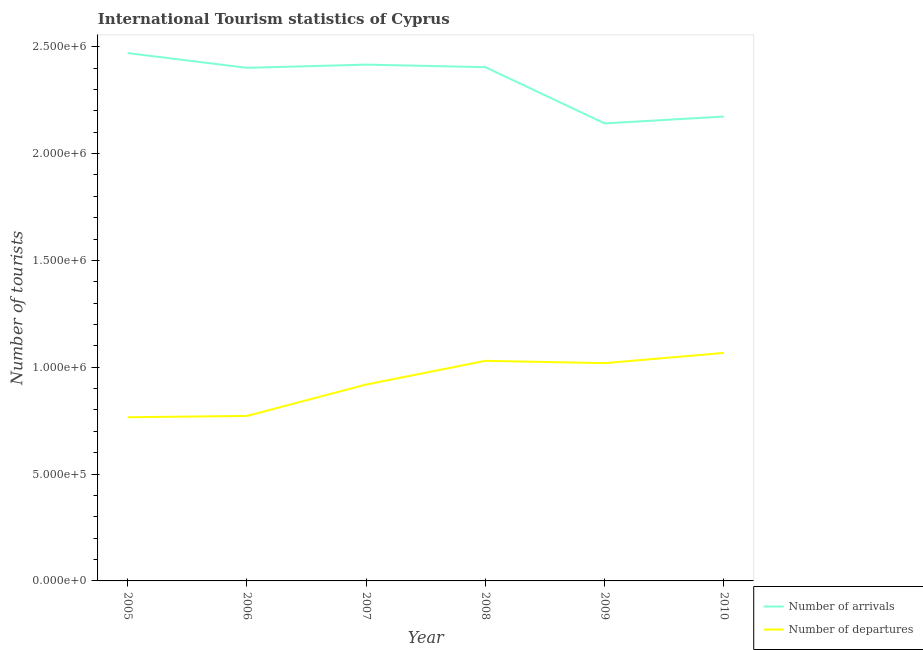Does the line corresponding to number of tourist arrivals intersect with the line corresponding to number of tourist departures?
Ensure brevity in your answer.  No. Is the number of lines equal to the number of legend labels?
Your answer should be very brief. Yes. What is the number of tourist arrivals in 2007?
Your response must be concise. 2.42e+06. Across all years, what is the maximum number of tourist departures?
Offer a very short reply. 1.07e+06. Across all years, what is the minimum number of tourist departures?
Provide a short and direct response. 7.66e+05. In which year was the number of tourist arrivals maximum?
Offer a very short reply. 2005. In which year was the number of tourist arrivals minimum?
Offer a terse response. 2009. What is the total number of tourist arrivals in the graph?
Make the answer very short. 1.40e+07. What is the difference between the number of tourist arrivals in 2009 and that in 2010?
Provide a succinct answer. -3.20e+04. What is the difference between the number of tourist arrivals in 2006 and the number of tourist departures in 2008?
Your response must be concise. 1.37e+06. What is the average number of tourist arrivals per year?
Give a very brief answer. 2.33e+06. In the year 2008, what is the difference between the number of tourist departures and number of tourist arrivals?
Ensure brevity in your answer.  -1.37e+06. What is the ratio of the number of tourist departures in 2007 to that in 2010?
Offer a terse response. 0.86. Is the number of tourist arrivals in 2006 less than that in 2008?
Your answer should be compact. Yes. Is the difference between the number of tourist departures in 2005 and 2007 greater than the difference between the number of tourist arrivals in 2005 and 2007?
Give a very brief answer. No. What is the difference between the highest and the second highest number of tourist departures?
Offer a very short reply. 3.70e+04. What is the difference between the highest and the lowest number of tourist arrivals?
Provide a succinct answer. 3.29e+05. In how many years, is the number of tourist arrivals greater than the average number of tourist arrivals taken over all years?
Your answer should be very brief. 4. Is the number of tourist departures strictly less than the number of tourist arrivals over the years?
Your response must be concise. Yes. How many lines are there?
Make the answer very short. 2. How many years are there in the graph?
Offer a terse response. 6. What is the difference between two consecutive major ticks on the Y-axis?
Offer a terse response. 5.00e+05. Are the values on the major ticks of Y-axis written in scientific E-notation?
Keep it short and to the point. Yes. Where does the legend appear in the graph?
Your response must be concise. Bottom right. What is the title of the graph?
Offer a very short reply. International Tourism statistics of Cyprus. Does "Export" appear as one of the legend labels in the graph?
Offer a terse response. No. What is the label or title of the X-axis?
Offer a terse response. Year. What is the label or title of the Y-axis?
Your answer should be compact. Number of tourists. What is the Number of tourists in Number of arrivals in 2005?
Ensure brevity in your answer.  2.47e+06. What is the Number of tourists in Number of departures in 2005?
Give a very brief answer. 7.66e+05. What is the Number of tourists in Number of arrivals in 2006?
Offer a terse response. 2.40e+06. What is the Number of tourists in Number of departures in 2006?
Your response must be concise. 7.72e+05. What is the Number of tourists in Number of arrivals in 2007?
Give a very brief answer. 2.42e+06. What is the Number of tourists in Number of departures in 2007?
Give a very brief answer. 9.19e+05. What is the Number of tourists in Number of arrivals in 2008?
Provide a short and direct response. 2.40e+06. What is the Number of tourists in Number of departures in 2008?
Make the answer very short. 1.03e+06. What is the Number of tourists in Number of arrivals in 2009?
Offer a terse response. 2.14e+06. What is the Number of tourists of Number of departures in 2009?
Make the answer very short. 1.02e+06. What is the Number of tourists of Number of arrivals in 2010?
Provide a short and direct response. 2.17e+06. What is the Number of tourists in Number of departures in 2010?
Ensure brevity in your answer.  1.07e+06. Across all years, what is the maximum Number of tourists in Number of arrivals?
Your answer should be compact. 2.47e+06. Across all years, what is the maximum Number of tourists of Number of departures?
Your response must be concise. 1.07e+06. Across all years, what is the minimum Number of tourists in Number of arrivals?
Provide a succinct answer. 2.14e+06. Across all years, what is the minimum Number of tourists in Number of departures?
Your answer should be compact. 7.66e+05. What is the total Number of tourists of Number of arrivals in the graph?
Your answer should be compact. 1.40e+07. What is the total Number of tourists of Number of departures in the graph?
Make the answer very short. 5.57e+06. What is the difference between the Number of tourists in Number of arrivals in 2005 and that in 2006?
Your response must be concise. 6.90e+04. What is the difference between the Number of tourists of Number of departures in 2005 and that in 2006?
Make the answer very short. -6000. What is the difference between the Number of tourists in Number of arrivals in 2005 and that in 2007?
Your answer should be compact. 5.40e+04. What is the difference between the Number of tourists of Number of departures in 2005 and that in 2007?
Your answer should be very brief. -1.53e+05. What is the difference between the Number of tourists of Number of arrivals in 2005 and that in 2008?
Your response must be concise. 6.60e+04. What is the difference between the Number of tourists in Number of departures in 2005 and that in 2008?
Offer a very short reply. -2.64e+05. What is the difference between the Number of tourists in Number of arrivals in 2005 and that in 2009?
Provide a short and direct response. 3.29e+05. What is the difference between the Number of tourists in Number of departures in 2005 and that in 2009?
Offer a terse response. -2.53e+05. What is the difference between the Number of tourists of Number of arrivals in 2005 and that in 2010?
Your answer should be very brief. 2.97e+05. What is the difference between the Number of tourists of Number of departures in 2005 and that in 2010?
Offer a terse response. -3.01e+05. What is the difference between the Number of tourists of Number of arrivals in 2006 and that in 2007?
Your response must be concise. -1.50e+04. What is the difference between the Number of tourists in Number of departures in 2006 and that in 2007?
Offer a terse response. -1.47e+05. What is the difference between the Number of tourists in Number of arrivals in 2006 and that in 2008?
Offer a very short reply. -3000. What is the difference between the Number of tourists in Number of departures in 2006 and that in 2008?
Provide a short and direct response. -2.58e+05. What is the difference between the Number of tourists of Number of arrivals in 2006 and that in 2009?
Ensure brevity in your answer.  2.60e+05. What is the difference between the Number of tourists of Number of departures in 2006 and that in 2009?
Your response must be concise. -2.47e+05. What is the difference between the Number of tourists of Number of arrivals in 2006 and that in 2010?
Offer a very short reply. 2.28e+05. What is the difference between the Number of tourists in Number of departures in 2006 and that in 2010?
Give a very brief answer. -2.95e+05. What is the difference between the Number of tourists of Number of arrivals in 2007 and that in 2008?
Give a very brief answer. 1.20e+04. What is the difference between the Number of tourists in Number of departures in 2007 and that in 2008?
Make the answer very short. -1.11e+05. What is the difference between the Number of tourists of Number of arrivals in 2007 and that in 2009?
Give a very brief answer. 2.75e+05. What is the difference between the Number of tourists in Number of arrivals in 2007 and that in 2010?
Provide a succinct answer. 2.43e+05. What is the difference between the Number of tourists of Number of departures in 2007 and that in 2010?
Provide a short and direct response. -1.48e+05. What is the difference between the Number of tourists of Number of arrivals in 2008 and that in 2009?
Your answer should be very brief. 2.63e+05. What is the difference between the Number of tourists of Number of departures in 2008 and that in 2009?
Your response must be concise. 1.10e+04. What is the difference between the Number of tourists of Number of arrivals in 2008 and that in 2010?
Ensure brevity in your answer.  2.31e+05. What is the difference between the Number of tourists of Number of departures in 2008 and that in 2010?
Make the answer very short. -3.70e+04. What is the difference between the Number of tourists of Number of arrivals in 2009 and that in 2010?
Offer a very short reply. -3.20e+04. What is the difference between the Number of tourists in Number of departures in 2009 and that in 2010?
Make the answer very short. -4.80e+04. What is the difference between the Number of tourists of Number of arrivals in 2005 and the Number of tourists of Number of departures in 2006?
Make the answer very short. 1.70e+06. What is the difference between the Number of tourists of Number of arrivals in 2005 and the Number of tourists of Number of departures in 2007?
Keep it short and to the point. 1.55e+06. What is the difference between the Number of tourists in Number of arrivals in 2005 and the Number of tourists in Number of departures in 2008?
Your response must be concise. 1.44e+06. What is the difference between the Number of tourists in Number of arrivals in 2005 and the Number of tourists in Number of departures in 2009?
Offer a very short reply. 1.45e+06. What is the difference between the Number of tourists in Number of arrivals in 2005 and the Number of tourists in Number of departures in 2010?
Provide a succinct answer. 1.40e+06. What is the difference between the Number of tourists in Number of arrivals in 2006 and the Number of tourists in Number of departures in 2007?
Offer a very short reply. 1.48e+06. What is the difference between the Number of tourists in Number of arrivals in 2006 and the Number of tourists in Number of departures in 2008?
Offer a terse response. 1.37e+06. What is the difference between the Number of tourists in Number of arrivals in 2006 and the Number of tourists in Number of departures in 2009?
Your answer should be very brief. 1.38e+06. What is the difference between the Number of tourists of Number of arrivals in 2006 and the Number of tourists of Number of departures in 2010?
Your answer should be very brief. 1.33e+06. What is the difference between the Number of tourists in Number of arrivals in 2007 and the Number of tourists in Number of departures in 2008?
Offer a terse response. 1.39e+06. What is the difference between the Number of tourists of Number of arrivals in 2007 and the Number of tourists of Number of departures in 2009?
Keep it short and to the point. 1.40e+06. What is the difference between the Number of tourists of Number of arrivals in 2007 and the Number of tourists of Number of departures in 2010?
Give a very brief answer. 1.35e+06. What is the difference between the Number of tourists in Number of arrivals in 2008 and the Number of tourists in Number of departures in 2009?
Offer a terse response. 1.38e+06. What is the difference between the Number of tourists of Number of arrivals in 2008 and the Number of tourists of Number of departures in 2010?
Keep it short and to the point. 1.34e+06. What is the difference between the Number of tourists in Number of arrivals in 2009 and the Number of tourists in Number of departures in 2010?
Your answer should be very brief. 1.07e+06. What is the average Number of tourists in Number of arrivals per year?
Keep it short and to the point. 2.33e+06. What is the average Number of tourists of Number of departures per year?
Provide a short and direct response. 9.29e+05. In the year 2005, what is the difference between the Number of tourists in Number of arrivals and Number of tourists in Number of departures?
Offer a terse response. 1.70e+06. In the year 2006, what is the difference between the Number of tourists in Number of arrivals and Number of tourists in Number of departures?
Provide a short and direct response. 1.63e+06. In the year 2007, what is the difference between the Number of tourists in Number of arrivals and Number of tourists in Number of departures?
Provide a short and direct response. 1.50e+06. In the year 2008, what is the difference between the Number of tourists in Number of arrivals and Number of tourists in Number of departures?
Your answer should be compact. 1.37e+06. In the year 2009, what is the difference between the Number of tourists in Number of arrivals and Number of tourists in Number of departures?
Offer a very short reply. 1.12e+06. In the year 2010, what is the difference between the Number of tourists of Number of arrivals and Number of tourists of Number of departures?
Give a very brief answer. 1.11e+06. What is the ratio of the Number of tourists of Number of arrivals in 2005 to that in 2006?
Offer a terse response. 1.03. What is the ratio of the Number of tourists in Number of departures in 2005 to that in 2006?
Your response must be concise. 0.99. What is the ratio of the Number of tourists of Number of arrivals in 2005 to that in 2007?
Offer a terse response. 1.02. What is the ratio of the Number of tourists in Number of departures in 2005 to that in 2007?
Ensure brevity in your answer.  0.83. What is the ratio of the Number of tourists of Number of arrivals in 2005 to that in 2008?
Keep it short and to the point. 1.03. What is the ratio of the Number of tourists of Number of departures in 2005 to that in 2008?
Give a very brief answer. 0.74. What is the ratio of the Number of tourists of Number of arrivals in 2005 to that in 2009?
Ensure brevity in your answer.  1.15. What is the ratio of the Number of tourists in Number of departures in 2005 to that in 2009?
Offer a very short reply. 0.75. What is the ratio of the Number of tourists in Number of arrivals in 2005 to that in 2010?
Keep it short and to the point. 1.14. What is the ratio of the Number of tourists of Number of departures in 2005 to that in 2010?
Offer a terse response. 0.72. What is the ratio of the Number of tourists in Number of arrivals in 2006 to that in 2007?
Your response must be concise. 0.99. What is the ratio of the Number of tourists in Number of departures in 2006 to that in 2007?
Offer a very short reply. 0.84. What is the ratio of the Number of tourists of Number of arrivals in 2006 to that in 2008?
Offer a very short reply. 1. What is the ratio of the Number of tourists of Number of departures in 2006 to that in 2008?
Your response must be concise. 0.75. What is the ratio of the Number of tourists in Number of arrivals in 2006 to that in 2009?
Make the answer very short. 1.12. What is the ratio of the Number of tourists of Number of departures in 2006 to that in 2009?
Provide a succinct answer. 0.76. What is the ratio of the Number of tourists in Number of arrivals in 2006 to that in 2010?
Give a very brief answer. 1.1. What is the ratio of the Number of tourists of Number of departures in 2006 to that in 2010?
Provide a succinct answer. 0.72. What is the ratio of the Number of tourists in Number of arrivals in 2007 to that in 2008?
Offer a terse response. 1. What is the ratio of the Number of tourists of Number of departures in 2007 to that in 2008?
Provide a succinct answer. 0.89. What is the ratio of the Number of tourists of Number of arrivals in 2007 to that in 2009?
Provide a short and direct response. 1.13. What is the ratio of the Number of tourists of Number of departures in 2007 to that in 2009?
Provide a succinct answer. 0.9. What is the ratio of the Number of tourists of Number of arrivals in 2007 to that in 2010?
Offer a terse response. 1.11. What is the ratio of the Number of tourists of Number of departures in 2007 to that in 2010?
Provide a short and direct response. 0.86. What is the ratio of the Number of tourists in Number of arrivals in 2008 to that in 2009?
Provide a succinct answer. 1.12. What is the ratio of the Number of tourists of Number of departures in 2008 to that in 2009?
Make the answer very short. 1.01. What is the ratio of the Number of tourists in Number of arrivals in 2008 to that in 2010?
Offer a very short reply. 1.11. What is the ratio of the Number of tourists in Number of departures in 2008 to that in 2010?
Provide a succinct answer. 0.97. What is the ratio of the Number of tourists of Number of departures in 2009 to that in 2010?
Ensure brevity in your answer.  0.95. What is the difference between the highest and the second highest Number of tourists in Number of arrivals?
Give a very brief answer. 5.40e+04. What is the difference between the highest and the second highest Number of tourists of Number of departures?
Your response must be concise. 3.70e+04. What is the difference between the highest and the lowest Number of tourists of Number of arrivals?
Your answer should be very brief. 3.29e+05. What is the difference between the highest and the lowest Number of tourists of Number of departures?
Your answer should be very brief. 3.01e+05. 